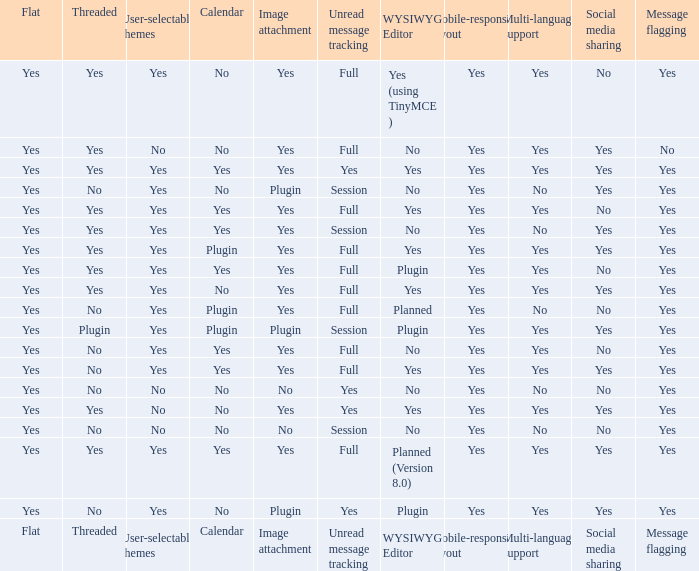Which WYSIWYG Editor has an Image attachment of yes, and a Calendar of plugin? Yes, Planned. 